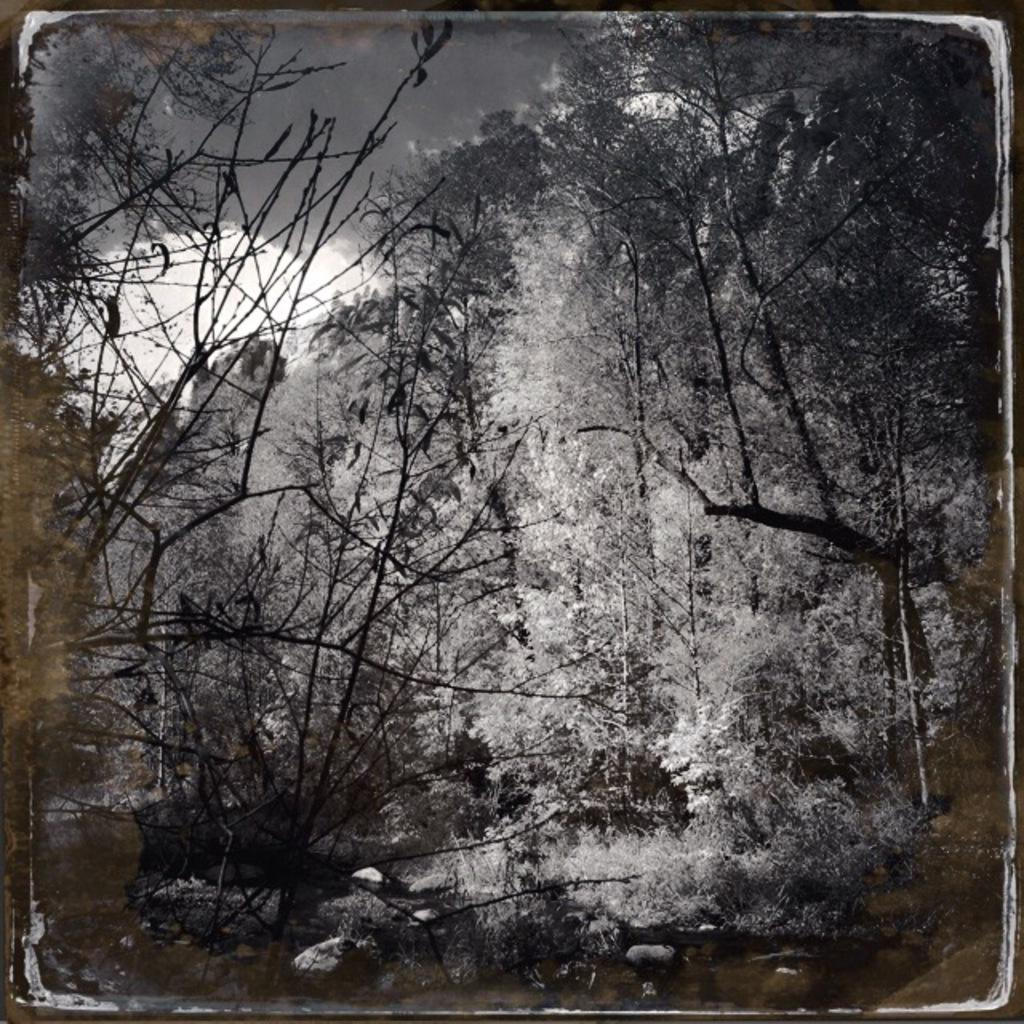What is the color scheme of the image? The image is black and white. What type of vegetation can be seen in the image? There are trees and plants in the image. What is visible at the top of the image? Clouds are visible at the top of the image. Can you see the bone structure of the face in the image? There is no face or bone structure present in the image; it features trees, plants, and clouds. 